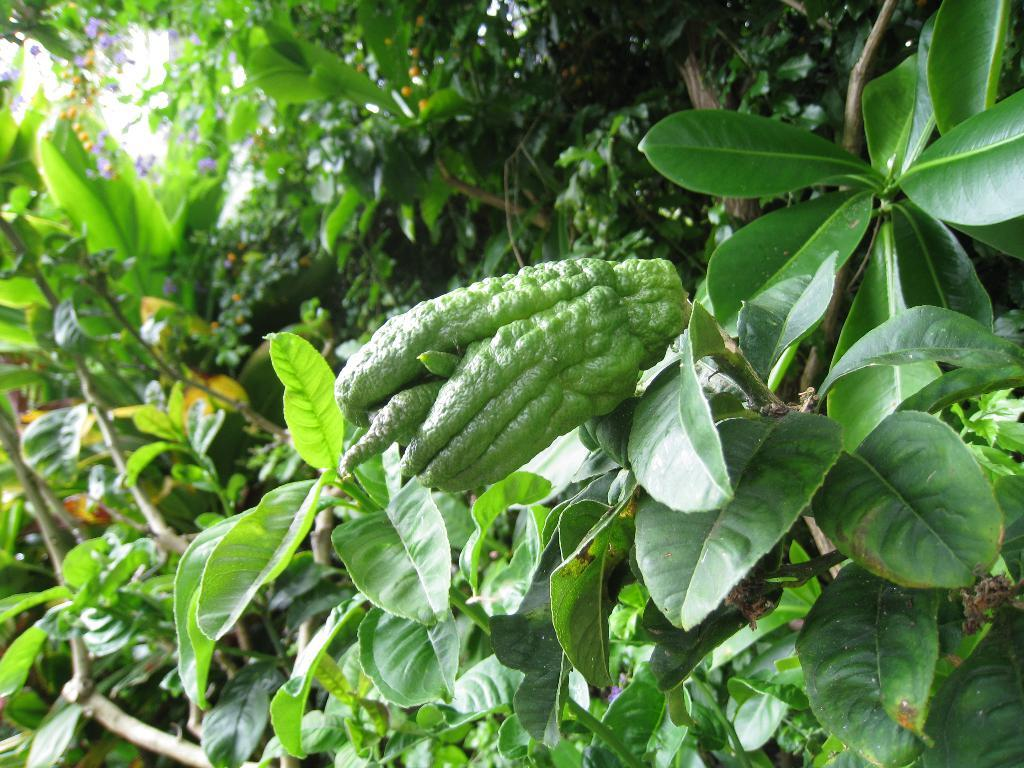What type of vegetation can be seen in the image? There are green leaves in the image. What is the main object in the center of the image? There is a green color object in the center of the image, which appears to be a vegetable. What else can be seen in the background of the image? There are other objects visible in the background of the image. How many holes are visible in the vegetable in the image? There are no holes visible in the vegetable in the image, as it is a solid object. What type of drink is being served with the vegetable in the image? There is no drink present in the image; it only features the vegetable and green leaves. 